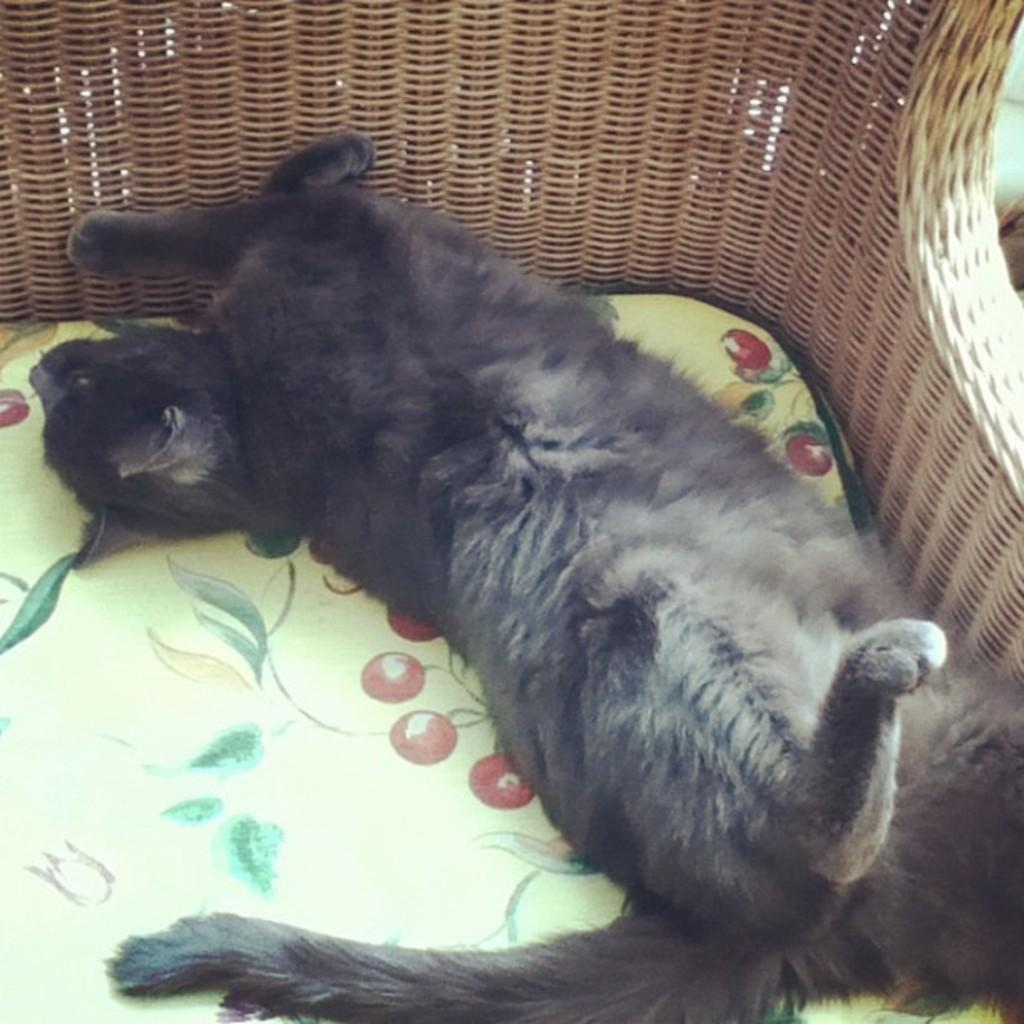What type of creature is present in the image? There is an animal in the image. Where is the animal located in the image? The animal is lying on a chair. What color is the animal in the image? The animal is black in color. What type of kite is the animal holding in the image? There is no kite present in the image; the animal is lying on a chair and is black in color. 